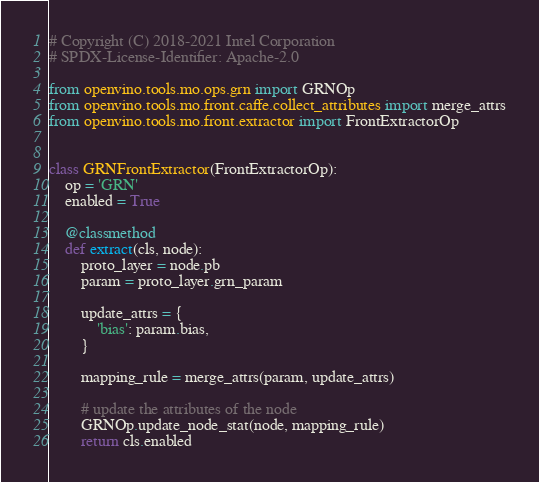Convert code to text. <code><loc_0><loc_0><loc_500><loc_500><_Python_># Copyright (C) 2018-2021 Intel Corporation
# SPDX-License-Identifier: Apache-2.0

from openvino.tools.mo.ops.grn import GRNOp
from openvino.tools.mo.front.caffe.collect_attributes import merge_attrs
from openvino.tools.mo.front.extractor import FrontExtractorOp


class GRNFrontExtractor(FrontExtractorOp):
    op = 'GRN'
    enabled = True

    @classmethod
    def extract(cls, node):
        proto_layer = node.pb
        param = proto_layer.grn_param

        update_attrs = {
            'bias': param.bias,
        }

        mapping_rule = merge_attrs(param, update_attrs)

        # update the attributes of the node
        GRNOp.update_node_stat(node, mapping_rule)
        return cls.enabled
</code> 